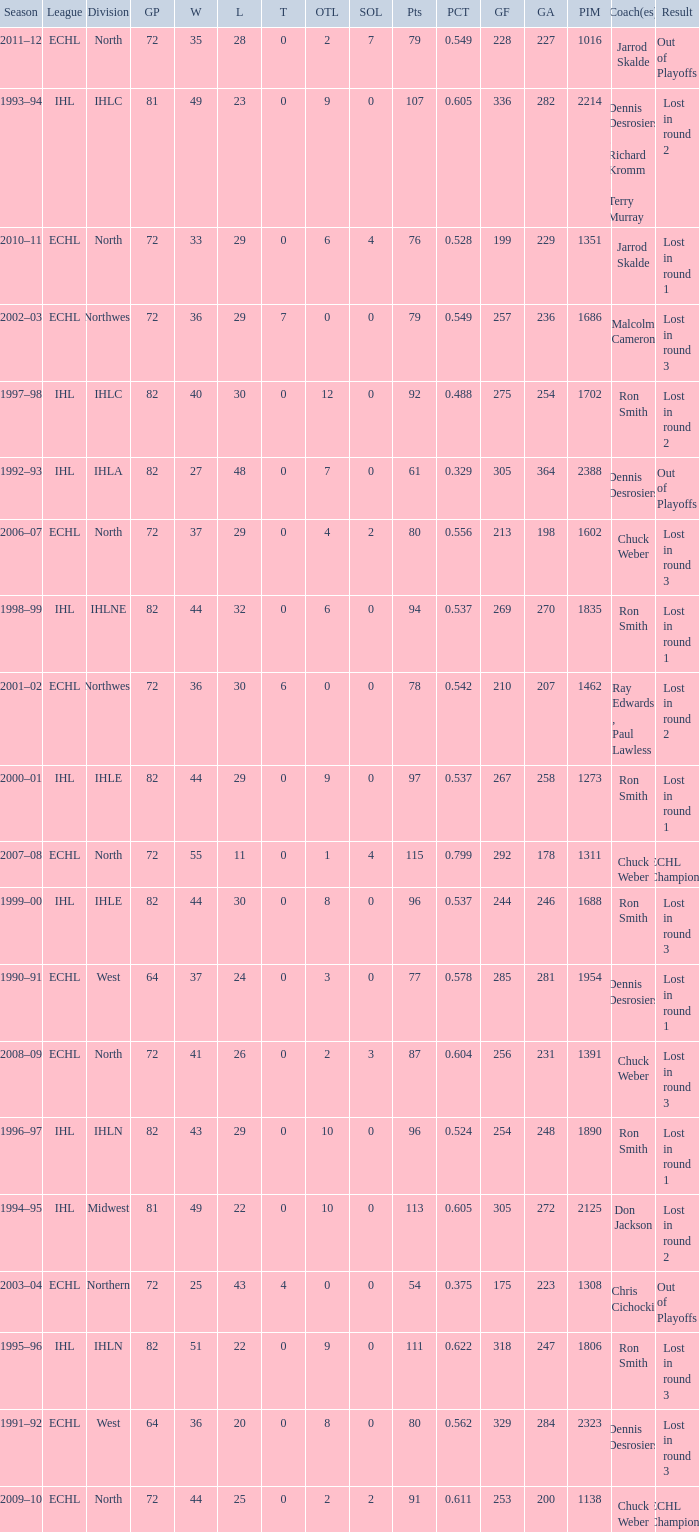How many season did the team lost in round 1 with a GP of 64? 1.0. 